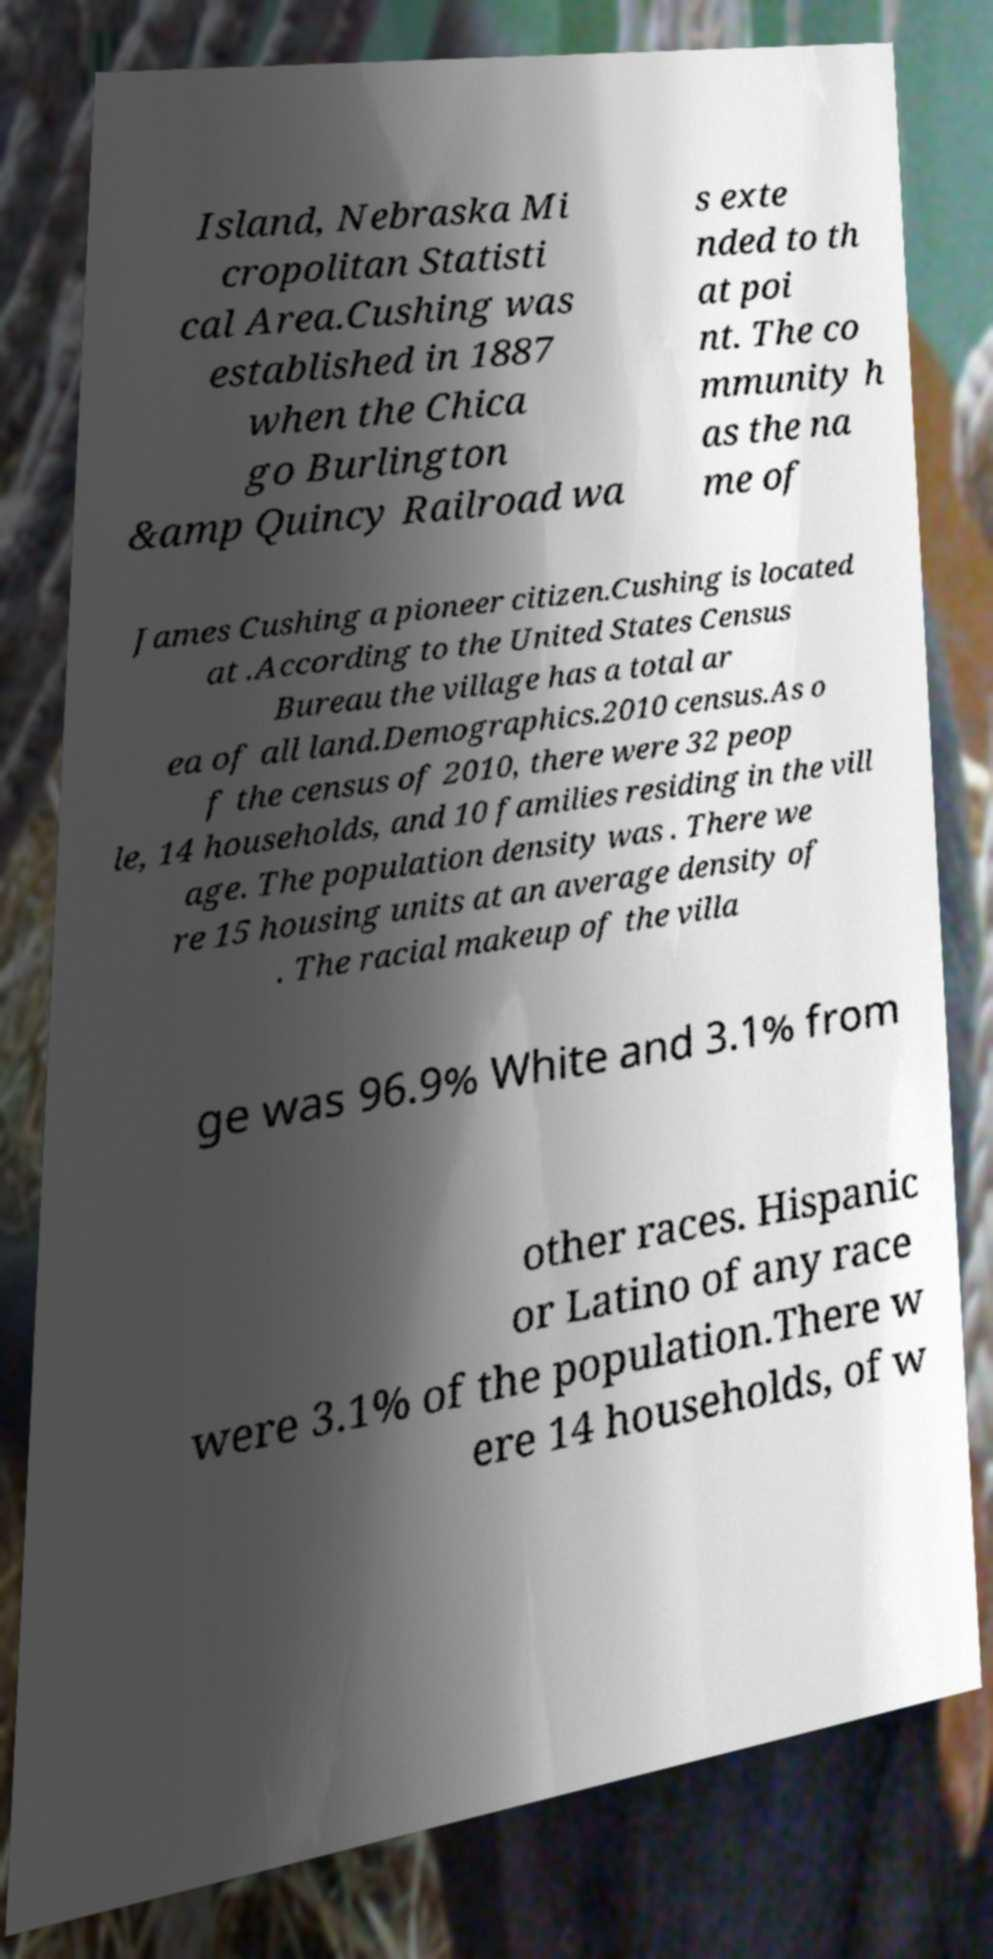Please read and relay the text visible in this image. What does it say? Island, Nebraska Mi cropolitan Statisti cal Area.Cushing was established in 1887 when the Chica go Burlington &amp Quincy Railroad wa s exte nded to th at poi nt. The co mmunity h as the na me of James Cushing a pioneer citizen.Cushing is located at .According to the United States Census Bureau the village has a total ar ea of all land.Demographics.2010 census.As o f the census of 2010, there were 32 peop le, 14 households, and 10 families residing in the vill age. The population density was . There we re 15 housing units at an average density of . The racial makeup of the villa ge was 96.9% White and 3.1% from other races. Hispanic or Latino of any race were 3.1% of the population.There w ere 14 households, of w 